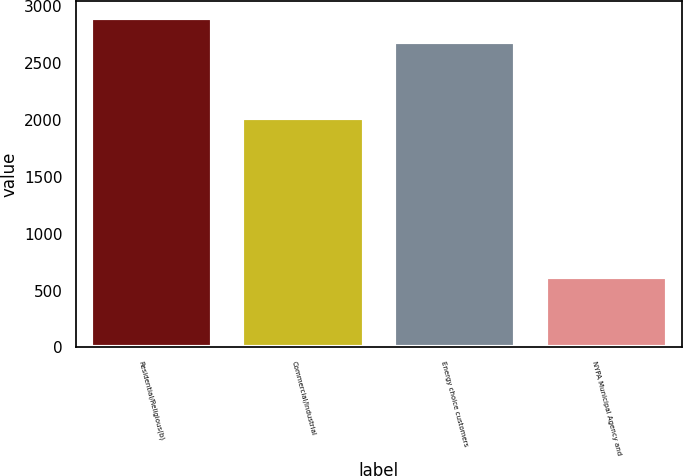Convert chart. <chart><loc_0><loc_0><loc_500><loc_500><bar_chart><fcel>Residential/Religious(b)<fcel>Commercial/Industrial<fcel>Energy choice customers<fcel>NYPA Municipal Agency and<nl><fcel>2898.8<fcel>2013<fcel>2683<fcel>615<nl></chart> 